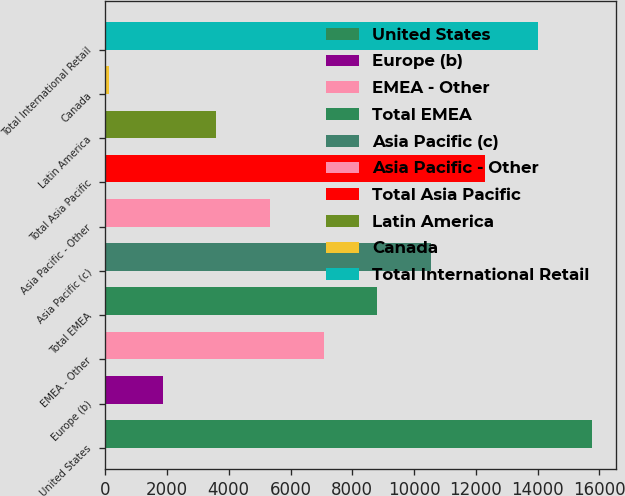<chart> <loc_0><loc_0><loc_500><loc_500><bar_chart><fcel>United States<fcel>Europe (b)<fcel>EMEA - Other<fcel>Total EMEA<fcel>Asia Pacific (c)<fcel>Asia Pacific - Other<fcel>Total Asia Pacific<fcel>Latin America<fcel>Canada<fcel>Total International Retail<nl><fcel>15763.1<fcel>1859.9<fcel>7073.6<fcel>8811.5<fcel>10549.4<fcel>5335.7<fcel>12287.3<fcel>3597.8<fcel>122<fcel>14025.2<nl></chart> 